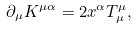<formula> <loc_0><loc_0><loc_500><loc_500>\partial _ { \mu } K ^ { \mu \alpha } = 2 { x ^ { \alpha } } T ^ { \mu } _ { \mu } ,</formula> 